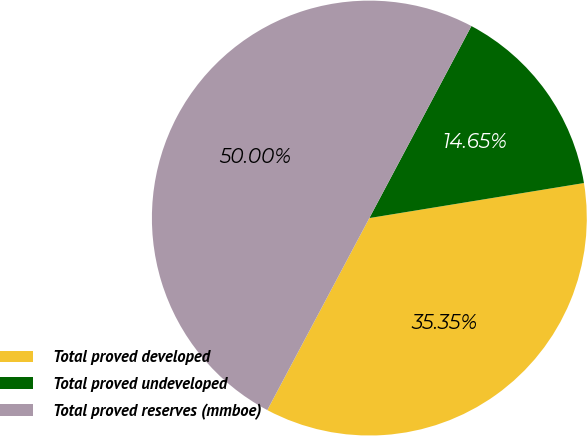Convert chart to OTSL. <chart><loc_0><loc_0><loc_500><loc_500><pie_chart><fcel>Total proved developed<fcel>Total proved undeveloped<fcel>Total proved reserves (mmboe)<nl><fcel>35.35%<fcel>14.65%<fcel>50.0%<nl></chart> 